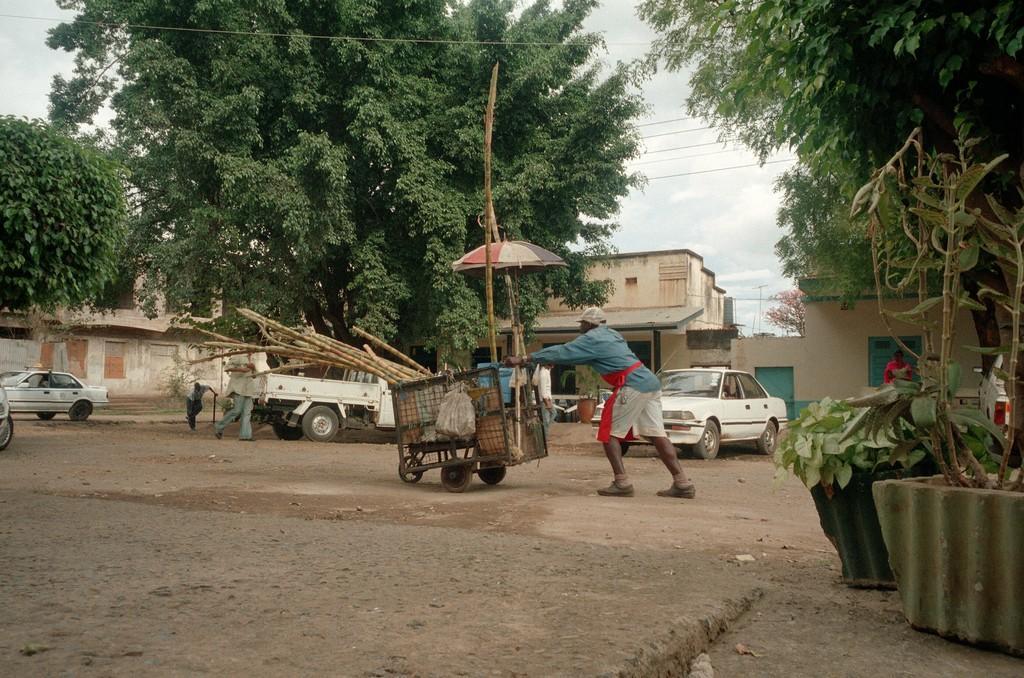Please provide a concise description of this image. In this image there is a person moving with vehicle and also around that there are so many other cars, buildings, trees and plant pots. 